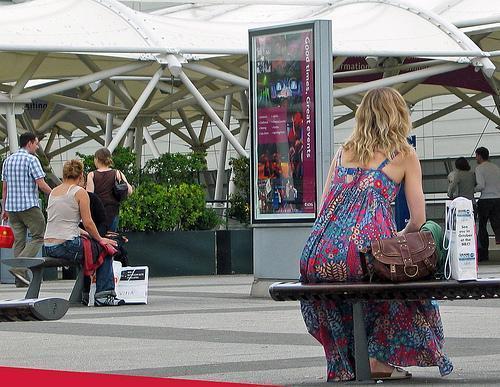How many colors are in dress?
Give a very brief answer. 3. 